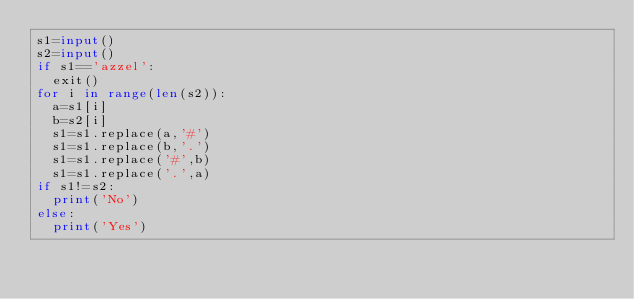Convert code to text. <code><loc_0><loc_0><loc_500><loc_500><_Python_>s1=input()
s2=input()
if s1=='azzel':
  exit()
for i in range(len(s2)):
  a=s1[i]
  b=s2[i]
  s1=s1.replace(a,'#')
  s1=s1.replace(b,'.')
  s1=s1.replace('#',b)
  s1=s1.replace('.',a)
if s1!=s2:
  print('No')
else:
  print('Yes')</code> 